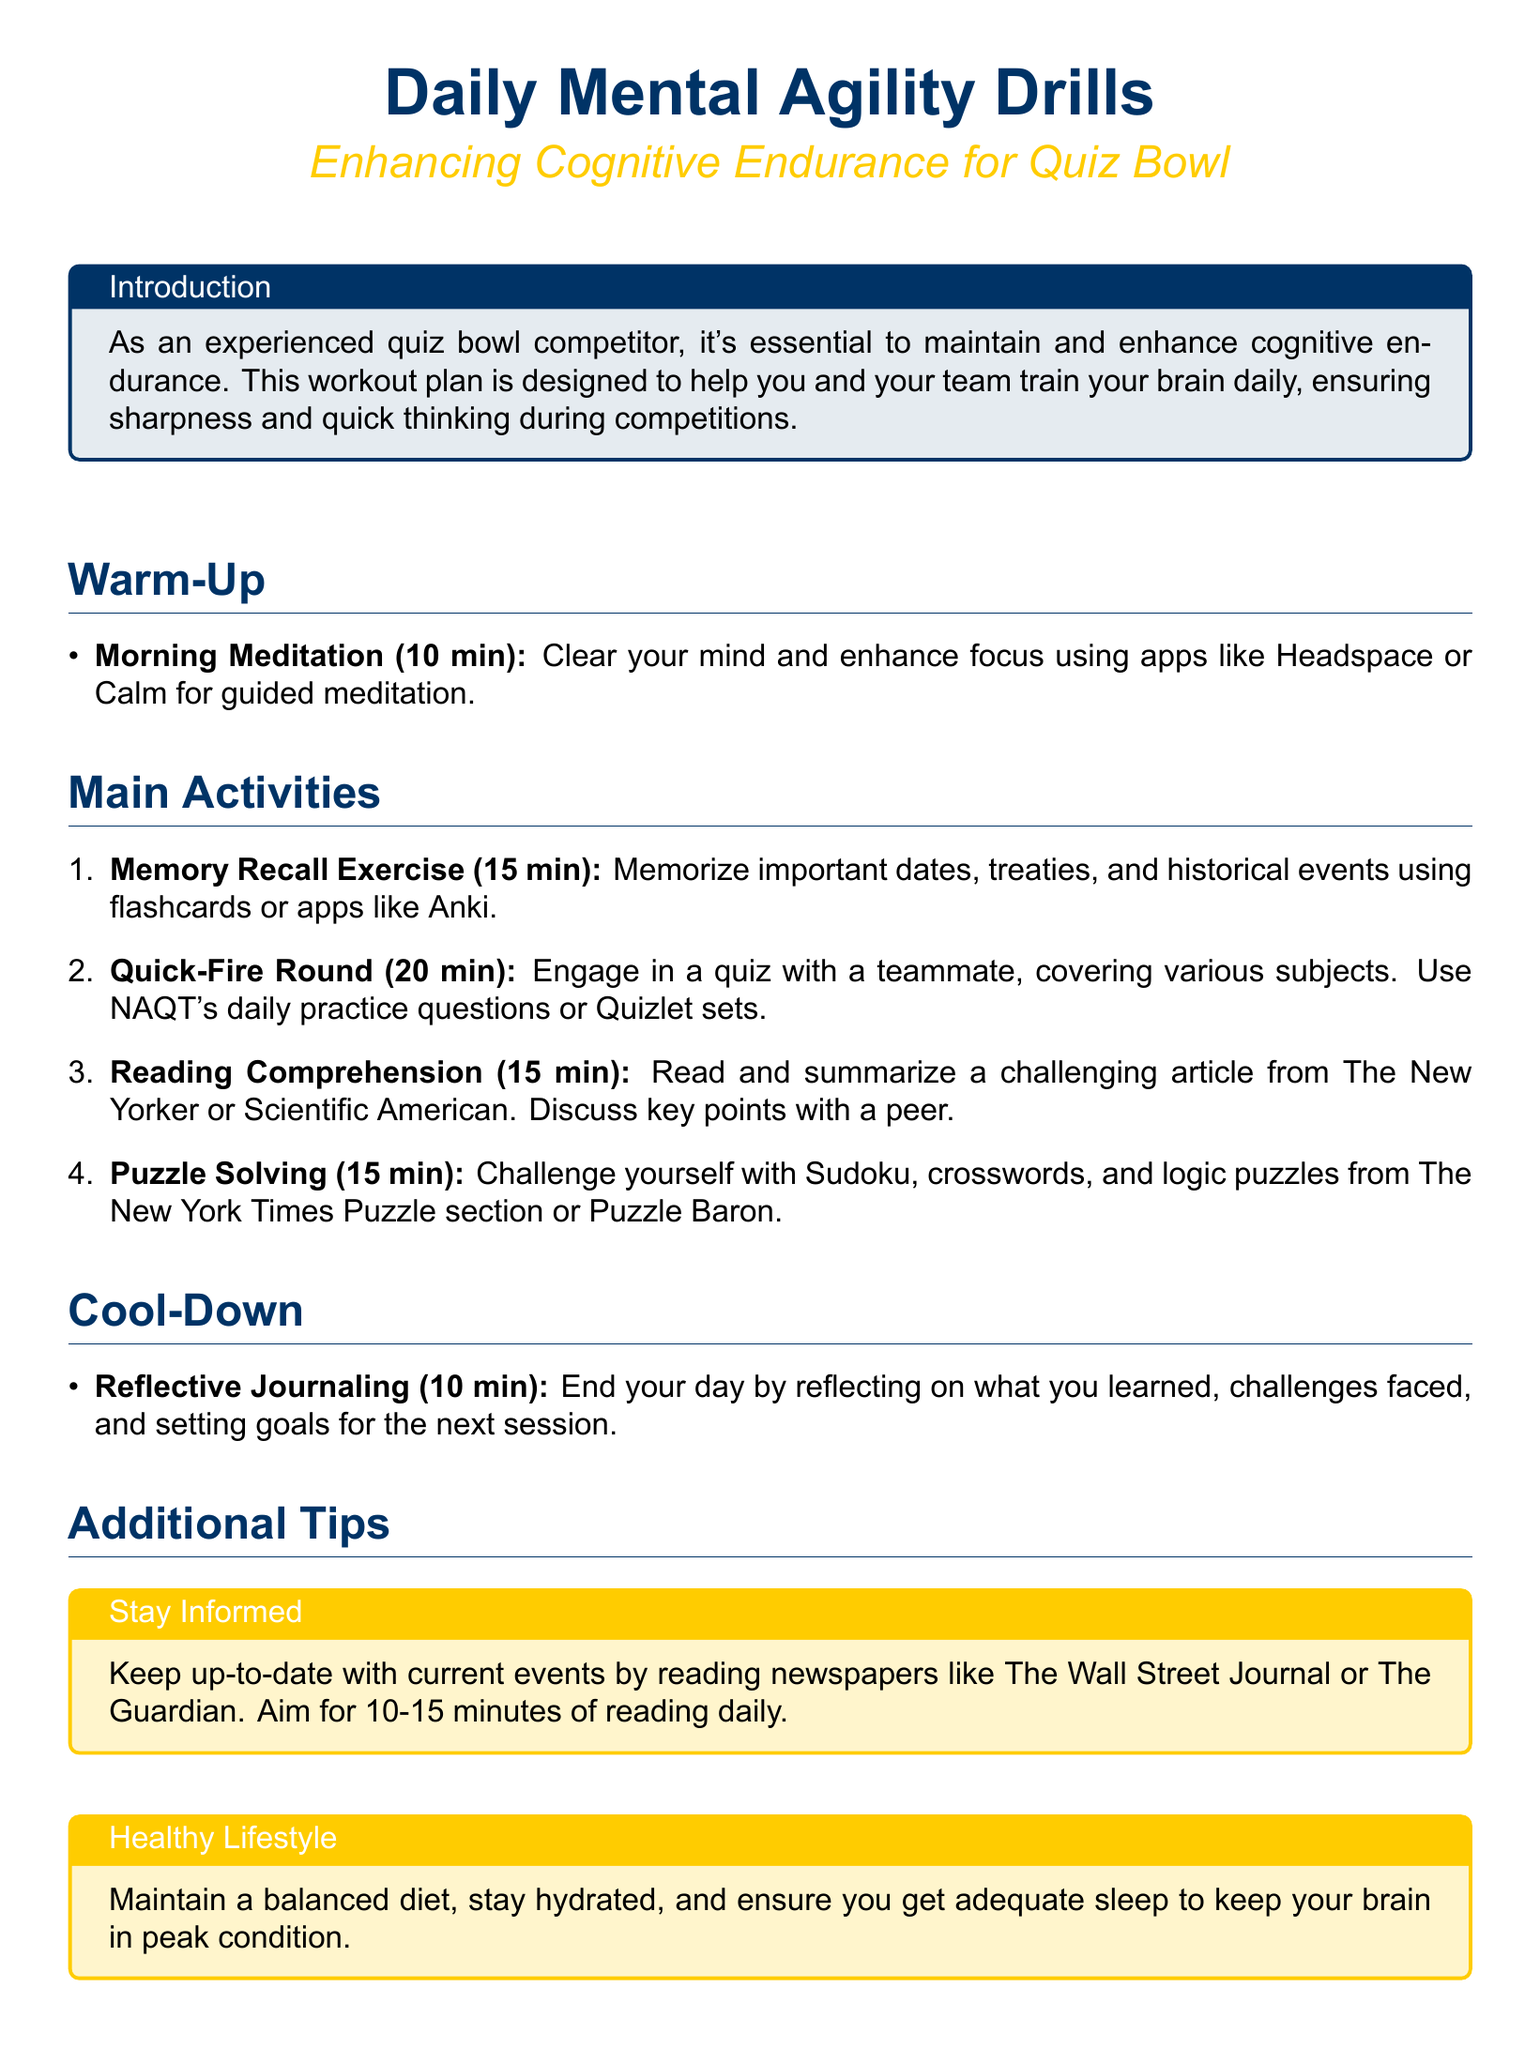What is the duration of the morning meditation? The morning meditation is a 10-minute exercise aimed at clearing the mind and enhancing focus.
Answer: 10 min How long is the memory recall exercise? The memory recall exercise is designed to last for 15 minutes to memorize important historical information.
Answer: 15 min What type of articles should be summarized during reading comprehension? The reading comprehension exercise includes summarizing challenging articles from specific publications.
Answer: The New Yorker or Scientific American How long is the quick-fire round scheduled for? The quick-fire round activity is allocated 20 minutes for engaging in a quiz.
Answer: 20 min What is the purpose of reflective journaling? Reflective journaling is meant to help competitors reflect on their learning and set goals.
Answer: Reflect on what you learned What should participants do to stay informed? To stay informed, participants should read newspapers for a specific duration daily.
Answer: 10-15 minutes Which type of puzzles are recommended for the puzzle-solving exercise? The document suggests various types of puzzles as part of the mental agility drills.
Answer: Sudoku, crosswords, and logic puzzles What is emphasized as crucial for maintaining peak cognitive condition? The document highlights an important lifestyle aspect to keep the brain functioning well.
Answer: Balanced diet What color is used as the main color in the document? The document uses a specific RGB color code for design purposes.
Answer: RGB(0,51,102) 